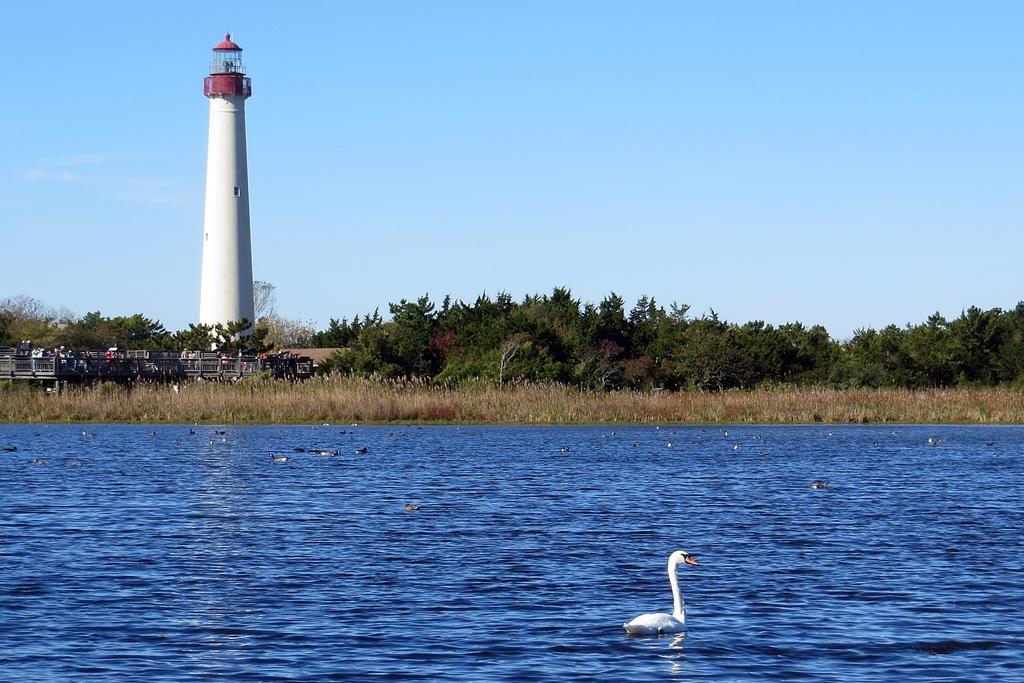Could you give a brief overview of what you see in this image? Here in this picture we can see a duck present in a river, as we can see water present all over there and on the ground we can see grass covered all over there and we can see trees and plants present over there and on left side we can see a lighthouse present over there. 